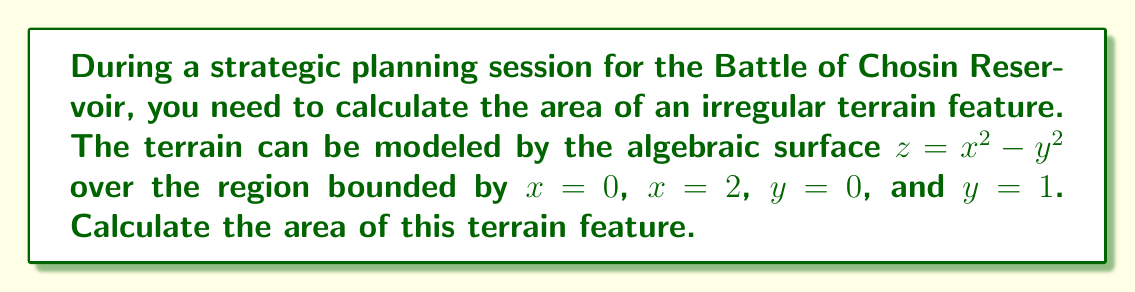Could you help me with this problem? To calculate the area of this irregular terrain, we need to use the surface area formula for a function $z = f(x,y)$ over a region R:

$$ A = \int\int_R \sqrt{1 + \left(\frac{\partial z}{\partial x}\right)^2 + \left(\frac{\partial z}{\partial y}\right)^2} \, dA $$

Step 1: Find the partial derivatives
$\frac{\partial z}{\partial x} = 2x$
$\frac{\partial z}{\partial y} = -2y$

Step 2: Substitute into the formula
$$ A = \int_0^1 \int_0^2 \sqrt{1 + (2x)^2 + (-2y)^2} \, dx \, dy $$

Step 3: Simplify the integrand
$$ A = \int_0^1 \int_0^2 \sqrt{1 + 4x^2 + 4y^2} \, dx \, dy $$

Step 4: This integral is difficult to evaluate analytically, so we'll use numerical integration. Using a computer algebra system or numerical integration tool, we can evaluate this double integral.

Step 5: After numerical integration, we find that the area is approximately 2.2957 square units.
Answer: $2.2957$ square units 